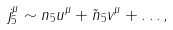<formula> <loc_0><loc_0><loc_500><loc_500>j ^ { \mu } _ { 5 } \sim n _ { 5 } u ^ { \mu } + \tilde { n } _ { 5 } v ^ { \mu } + \dots ,</formula> 